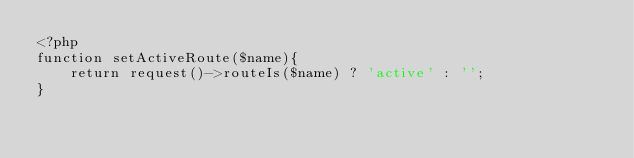<code> <loc_0><loc_0><loc_500><loc_500><_PHP_><?php
function setActiveRoute($name){
    return request()->routeIs($name) ? 'active' : '';
}
</code> 